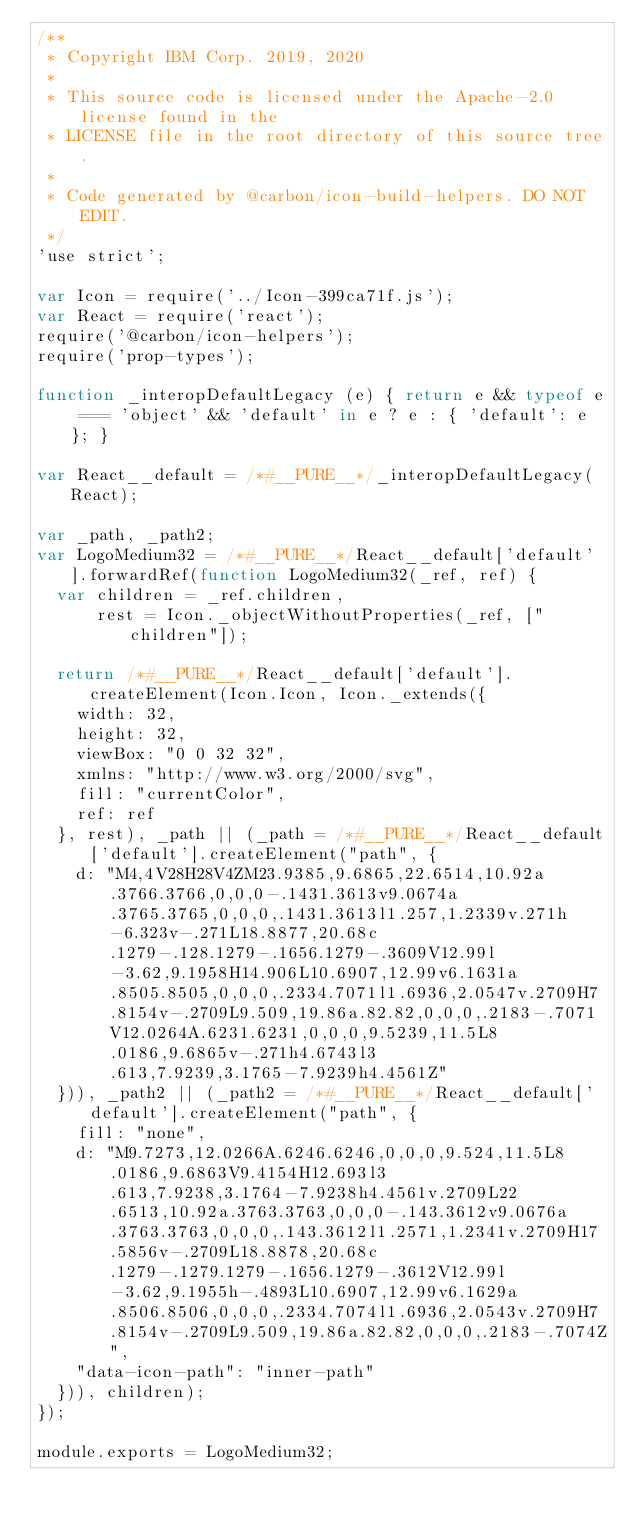Convert code to text. <code><loc_0><loc_0><loc_500><loc_500><_JavaScript_>/**
 * Copyright IBM Corp. 2019, 2020
 *
 * This source code is licensed under the Apache-2.0 license found in the
 * LICENSE file in the root directory of this source tree.
 *
 * Code generated by @carbon/icon-build-helpers. DO NOT EDIT.
 */
'use strict';

var Icon = require('../Icon-399ca71f.js');
var React = require('react');
require('@carbon/icon-helpers');
require('prop-types');

function _interopDefaultLegacy (e) { return e && typeof e === 'object' && 'default' in e ? e : { 'default': e }; }

var React__default = /*#__PURE__*/_interopDefaultLegacy(React);

var _path, _path2;
var LogoMedium32 = /*#__PURE__*/React__default['default'].forwardRef(function LogoMedium32(_ref, ref) {
  var children = _ref.children,
      rest = Icon._objectWithoutProperties(_ref, ["children"]);

  return /*#__PURE__*/React__default['default'].createElement(Icon.Icon, Icon._extends({
    width: 32,
    height: 32,
    viewBox: "0 0 32 32",
    xmlns: "http://www.w3.org/2000/svg",
    fill: "currentColor",
    ref: ref
  }, rest), _path || (_path = /*#__PURE__*/React__default['default'].createElement("path", {
    d: "M4,4V28H28V4ZM23.9385,9.6865,22.6514,10.92a.3766.3766,0,0,0-.1431.3613v9.0674a.3765.3765,0,0,0,.1431.3613l1.257,1.2339v.271h-6.323v-.271L18.8877,20.68c.1279-.128.1279-.1656.1279-.3609V12.99l-3.62,9.1958H14.906L10.6907,12.99v6.1631a.8505.8505,0,0,0,.2334.7071l1.6936,2.0547v.2709H7.8154v-.2709L9.509,19.86a.82.82,0,0,0,.2183-.7071V12.0264A.6231.6231,0,0,0,9.5239,11.5L8.0186,9.6865v-.271h4.6743l3.613,7.9239,3.1765-7.9239h4.4561Z"
  })), _path2 || (_path2 = /*#__PURE__*/React__default['default'].createElement("path", {
    fill: "none",
    d: "M9.7273,12.0266A.6246.6246,0,0,0,9.524,11.5L8.0186,9.6863V9.4154H12.693l3.613,7.9238,3.1764-7.9238h4.4561v.2709L22.6513,10.92a.3763.3763,0,0,0-.143.3612v9.0676a.3763.3763,0,0,0,.143.3612l1.2571,1.2341v.2709H17.5856v-.2709L18.8878,20.68c.1279-.1279.1279-.1656.1279-.3612V12.99l-3.62,9.1955h-.4893L10.6907,12.99v6.1629a.8506.8506,0,0,0,.2334.7074l1.6936,2.0543v.2709H7.8154v-.2709L9.509,19.86a.82.82,0,0,0,.2183-.7074Z",
    "data-icon-path": "inner-path"
  })), children);
});

module.exports = LogoMedium32;
</code> 